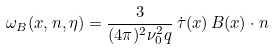<formula> <loc_0><loc_0><loc_500><loc_500>\omega _ { B } ( { x } , { n } , \eta ) = \frac { 3 } { ( 4 \pi ) ^ { 2 } \nu _ { 0 } ^ { 2 } q } \, \dot { \tau } ( { x } ) \, { B } ( { x } ) \cdot { n }</formula> 